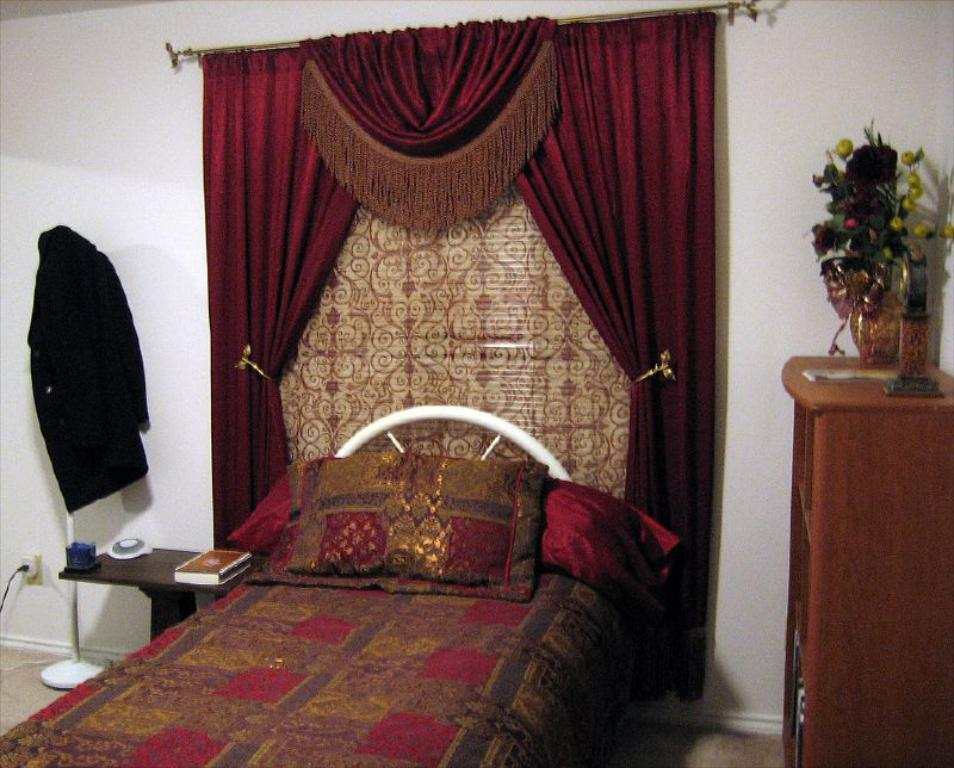What type of furniture is present in the image? There is a bed, a stool, and a cupboard in the image. What type of textile items can be seen in the image? There are curtains and pillows in the image. What personal item is visible in the image? There is a shirt in the image. What objects are related to reading or writing in the image? There is a book in the image. What decorative item is present in the image? There is a flower vase in the image. What is the background of the image? There is a wall in the background of the image. Where is the plate of honey located in the image? There is no plate of honey present in the image. 